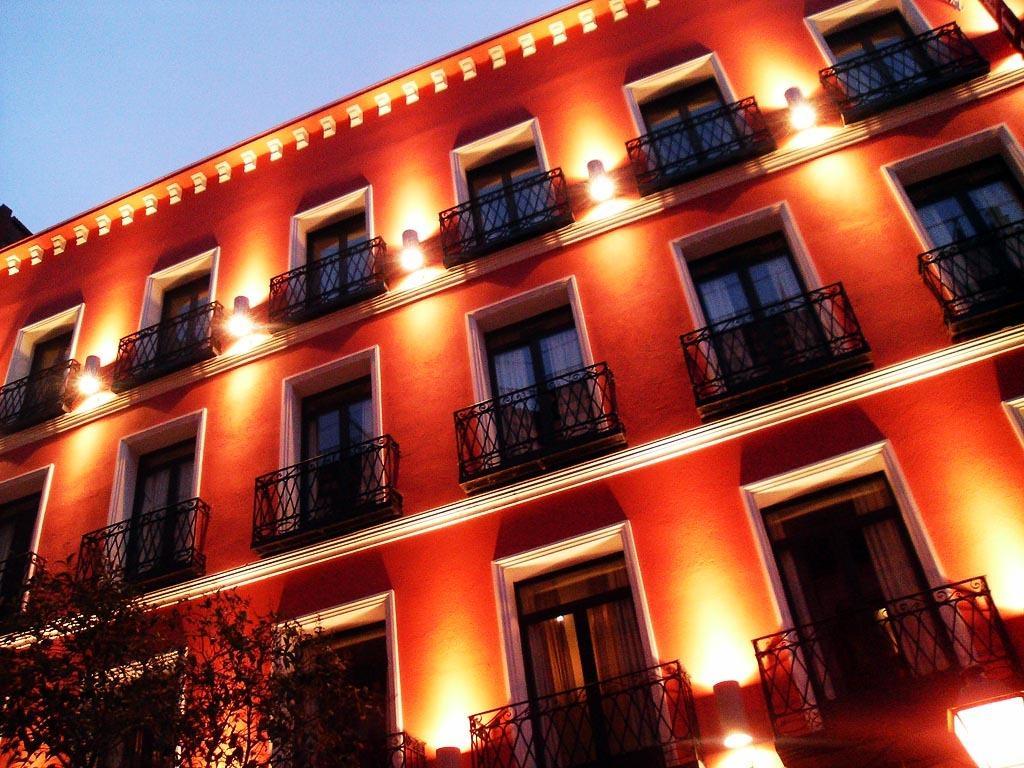In one or two sentences, can you explain what this image depicts? In this image I can see a building and the windows of the building with lights. I can see a tree in the left bottom corner. I can see the sky in the top left corner. 